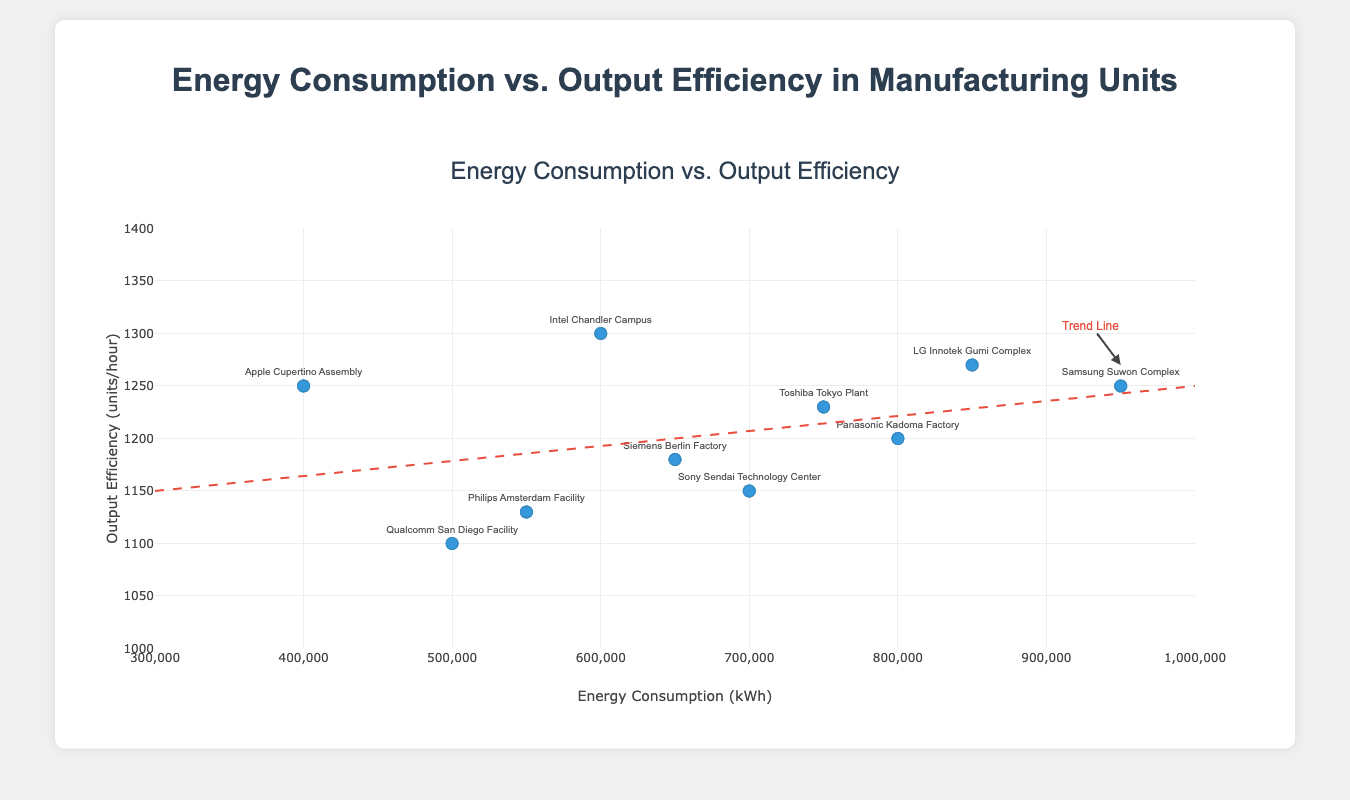How many manufacturing units are shown in the scatter plot? Counting the number of distinct points in the scatter plot gives the number of manufacturing units. There are 10 data points visible on the plot.
Answer: 10 What is the title of the scatter plot? The title is displayed at the top of the scatter plot. It reads "Energy Consumption vs. Output Efficiency".
Answer: Energy Consumption vs. Output Efficiency Which manufacturing unit has the lowest energy consumption? Locate the point on the X-axis with the lowest value, which corresponds to the energy consumption. The "Apple Cupertino Assembly" has the lowest energy consumption at 400,000 kWh.
Answer: Apple Cupertino Assembly Compare the output efficiency of the Samsung Suwon Complex and Apple Cupertino Assembly. Which one is more efficient? Looking at the Y-axis values for the two units, the Samsung Suwon Complex has an output efficiency of 1,250 units/hour, and the Apple Cupertino Assembly also has an output efficiency of 1,250 units/hour. They are equally efficient.
Answer: Equally efficient What is the most energy-efficient manufacturing unit based on the highest output efficiency? Find the highest point on the Y-axis which corresponds to the highest output efficiency. The Intel Chandler Campus has the highest output efficiency at 1,300 units/hour.
Answer: Intel Chandler Campus What is the average energy consumption across all the manufacturing units? Sum all the energy consumption values and divide by the number of units: (950,000 + 800,000 + 700,000 + 600,000 + 850,000 + 500,000 + 400,000 + 750,000 + 650,000 + 550,000) / 10 = 675,000 kWh.
Answer: 675,000 kWh Does the trend line suggest that higher energy consumption leads to higher output efficiency? The trend line generally slopes upwards from left to right, indicating a positive correlation where higher energy consumption is associated with higher output efficiency.
Answer: Yes Which manufacturing unit deviates the most from the trend line? Identify the data point farthest from the trend line. The Qualcomm San Diego Facility, with energy consumption of 500,000 kWh and output efficiency of 1,100 units/hour, seems to be the farthest point.
Answer: Qualcomm San Diego Facility 